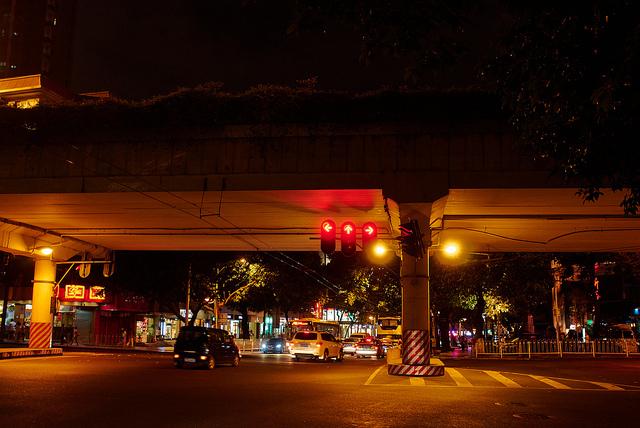How many red lights are shown?
Keep it brief. 3. What are the red signs?
Give a very brief answer. Arrows. How many colors is the bridge?
Be succinct. 1. Where was the picture taken of the vehicles and traffic signs?
Answer briefly. Outside. Is it night time?
Answer briefly. Yes. 